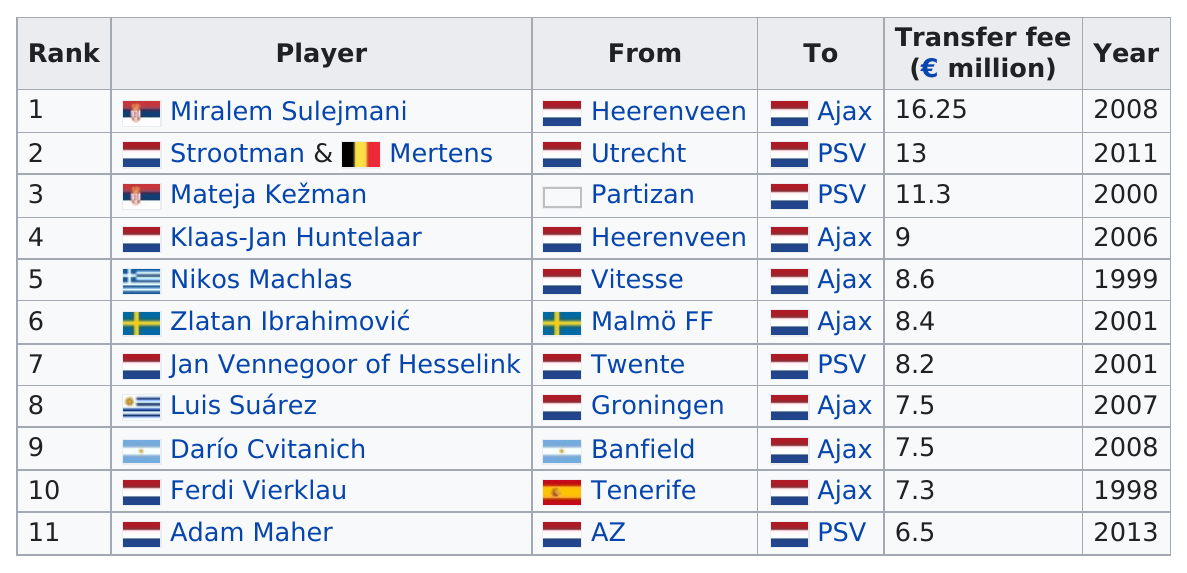Highlight a few significant elements in this photo. Dario Cvitanich, who played for Banfield before transferring to Ajax, is from Argentina. A total of 7 players have transferred to AFC Ajax. The combined fee for the top ranking player and the last ranking player is 22.75. Adam Maher is the last ranking player. The name of the player before Adam Maher is Ferdi Vierklau. 